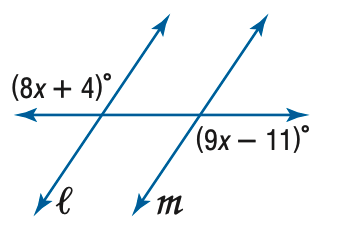Answer the mathemtical geometry problem and directly provide the correct option letter.
Question: Find x so that m \parallel n.
Choices: A: 7 B: 9 C: 11 D: 15 D 